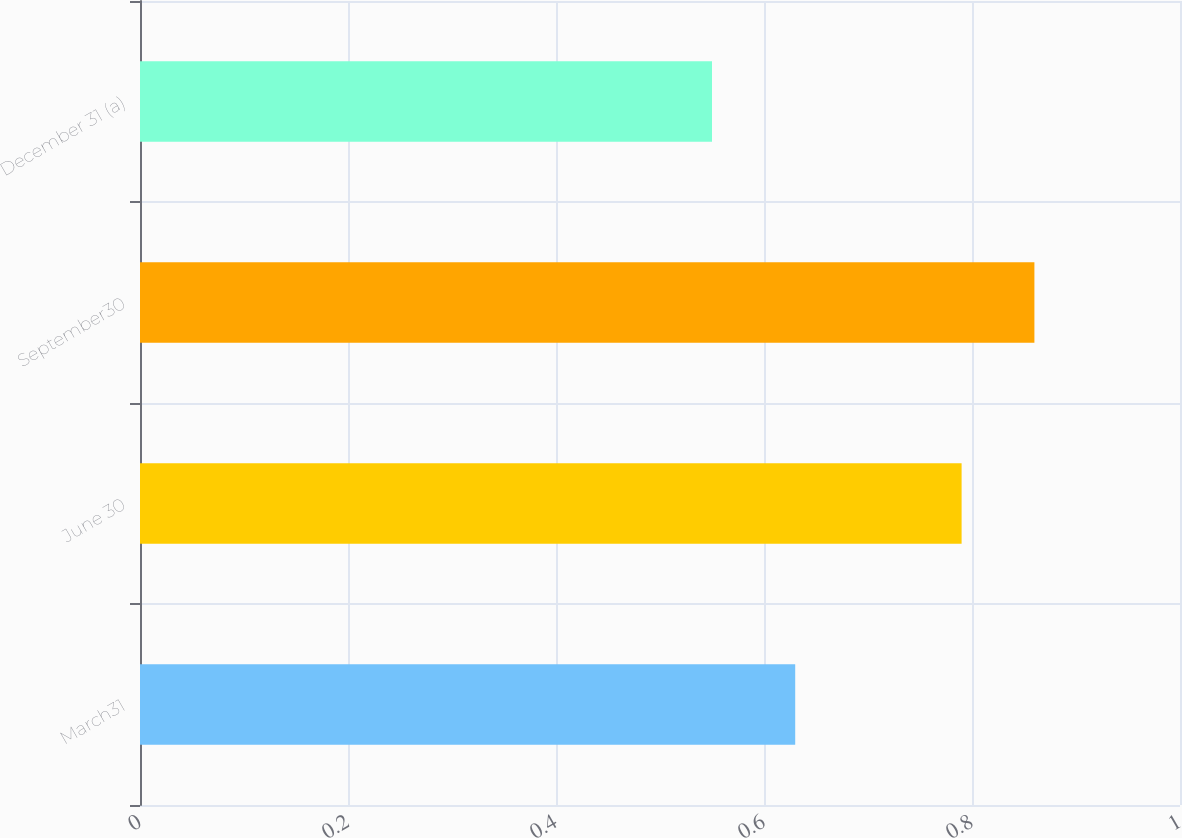Convert chart. <chart><loc_0><loc_0><loc_500><loc_500><bar_chart><fcel>March31<fcel>June 30<fcel>September30<fcel>December 31 (a)<nl><fcel>0.63<fcel>0.79<fcel>0.86<fcel>0.55<nl></chart> 